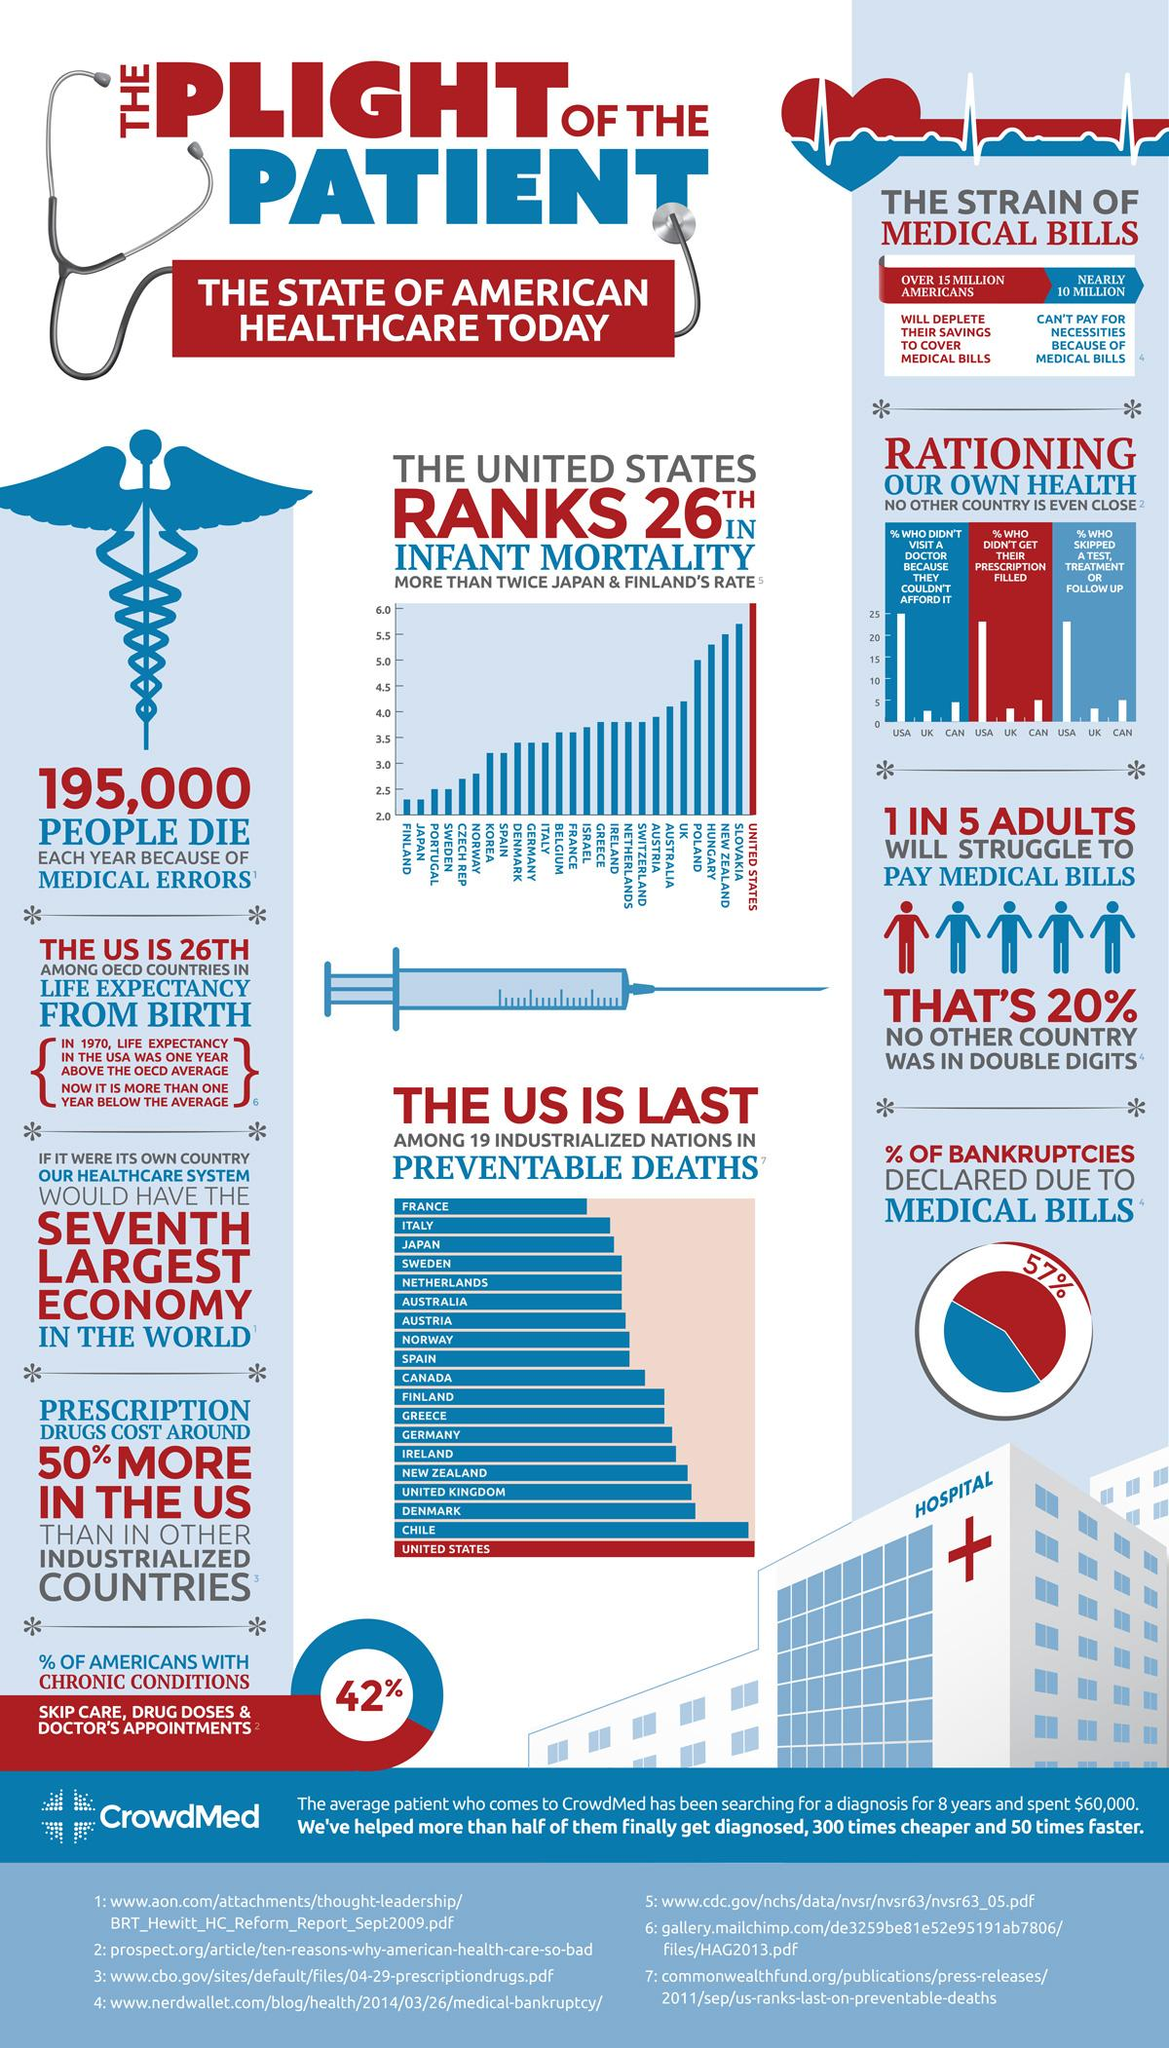Highlight a few significant elements in this photo. According to recent estimates, nearly 10 million Americans are unable to pay for their basic necessities due to medical bills. It is estimated that over 15 million Americans will deplete their savings in order to cover medical bills. An estimated 195,000 people in the United States died due to medical errors each year. According to recent data, approximately 57% of bankruptcies declared in the United States are due to medical bills. France is the leading industrialized nation in preventable deaths. 